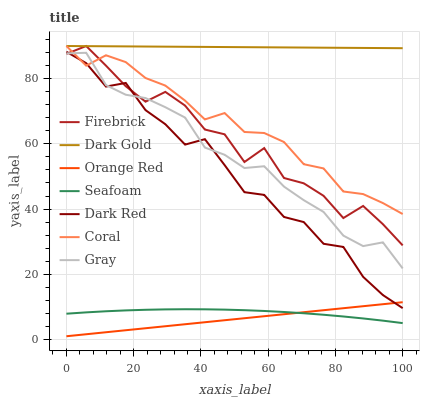Does Orange Red have the minimum area under the curve?
Answer yes or no. Yes. Does Dark Gold have the maximum area under the curve?
Answer yes or no. Yes. Does Dark Red have the minimum area under the curve?
Answer yes or no. No. Does Dark Red have the maximum area under the curve?
Answer yes or no. No. Is Orange Red the smoothest?
Answer yes or no. Yes. Is Firebrick the roughest?
Answer yes or no. Yes. Is Dark Gold the smoothest?
Answer yes or no. No. Is Dark Gold the roughest?
Answer yes or no. No. Does Orange Red have the lowest value?
Answer yes or no. Yes. Does Dark Red have the lowest value?
Answer yes or no. No. Does Firebrick have the highest value?
Answer yes or no. Yes. Does Dark Red have the highest value?
Answer yes or no. No. Is Orange Red less than Firebrick?
Answer yes or no. Yes. Is Firebrick greater than Seafoam?
Answer yes or no. Yes. Does Dark Red intersect Orange Red?
Answer yes or no. Yes. Is Dark Red less than Orange Red?
Answer yes or no. No. Is Dark Red greater than Orange Red?
Answer yes or no. No. Does Orange Red intersect Firebrick?
Answer yes or no. No. 